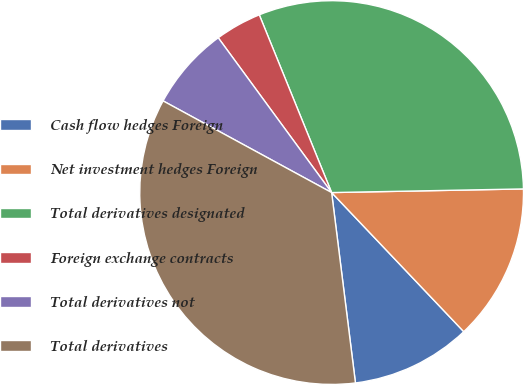<chart> <loc_0><loc_0><loc_500><loc_500><pie_chart><fcel>Cash flow hedges Foreign<fcel>Net investment hedges Foreign<fcel>Total derivatives designated<fcel>Foreign exchange contracts<fcel>Total derivatives not<fcel>Total derivatives<nl><fcel>10.11%<fcel>13.21%<fcel>30.85%<fcel>3.91%<fcel>7.01%<fcel>34.91%<nl></chart> 